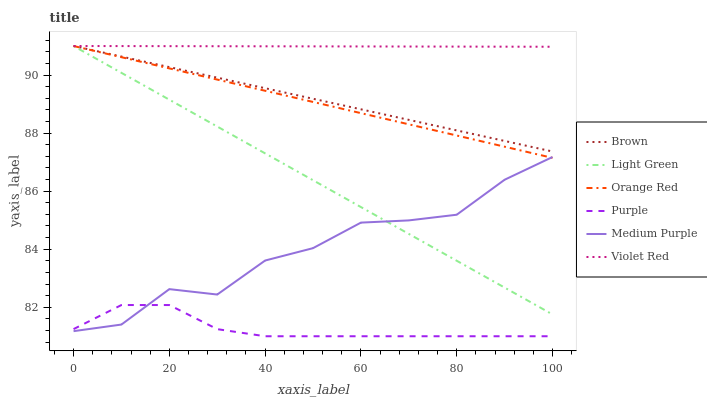Does Purple have the minimum area under the curve?
Answer yes or no. Yes. Does Violet Red have the maximum area under the curve?
Answer yes or no. Yes. Does Violet Red have the minimum area under the curve?
Answer yes or no. No. Does Purple have the maximum area under the curve?
Answer yes or no. No. Is Violet Red the smoothest?
Answer yes or no. Yes. Is Medium Purple the roughest?
Answer yes or no. Yes. Is Purple the smoothest?
Answer yes or no. No. Is Purple the roughest?
Answer yes or no. No. Does Violet Red have the lowest value?
Answer yes or no. No. Does Orange Red have the highest value?
Answer yes or no. Yes. Does Purple have the highest value?
Answer yes or no. No. Is Medium Purple less than Brown?
Answer yes or no. Yes. Is Violet Red greater than Medium Purple?
Answer yes or no. Yes. Does Medium Purple intersect Purple?
Answer yes or no. Yes. Is Medium Purple less than Purple?
Answer yes or no. No. Is Medium Purple greater than Purple?
Answer yes or no. No. Does Medium Purple intersect Brown?
Answer yes or no. No. 